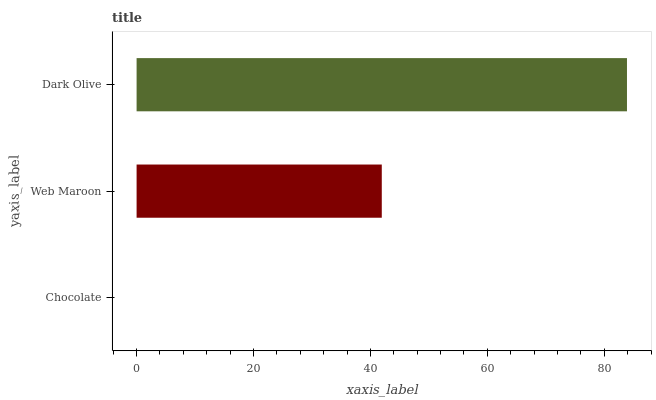Is Chocolate the minimum?
Answer yes or no. Yes. Is Dark Olive the maximum?
Answer yes or no. Yes. Is Web Maroon the minimum?
Answer yes or no. No. Is Web Maroon the maximum?
Answer yes or no. No. Is Web Maroon greater than Chocolate?
Answer yes or no. Yes. Is Chocolate less than Web Maroon?
Answer yes or no. Yes. Is Chocolate greater than Web Maroon?
Answer yes or no. No. Is Web Maroon less than Chocolate?
Answer yes or no. No. Is Web Maroon the high median?
Answer yes or no. Yes. Is Web Maroon the low median?
Answer yes or no. Yes. Is Dark Olive the high median?
Answer yes or no. No. Is Chocolate the low median?
Answer yes or no. No. 